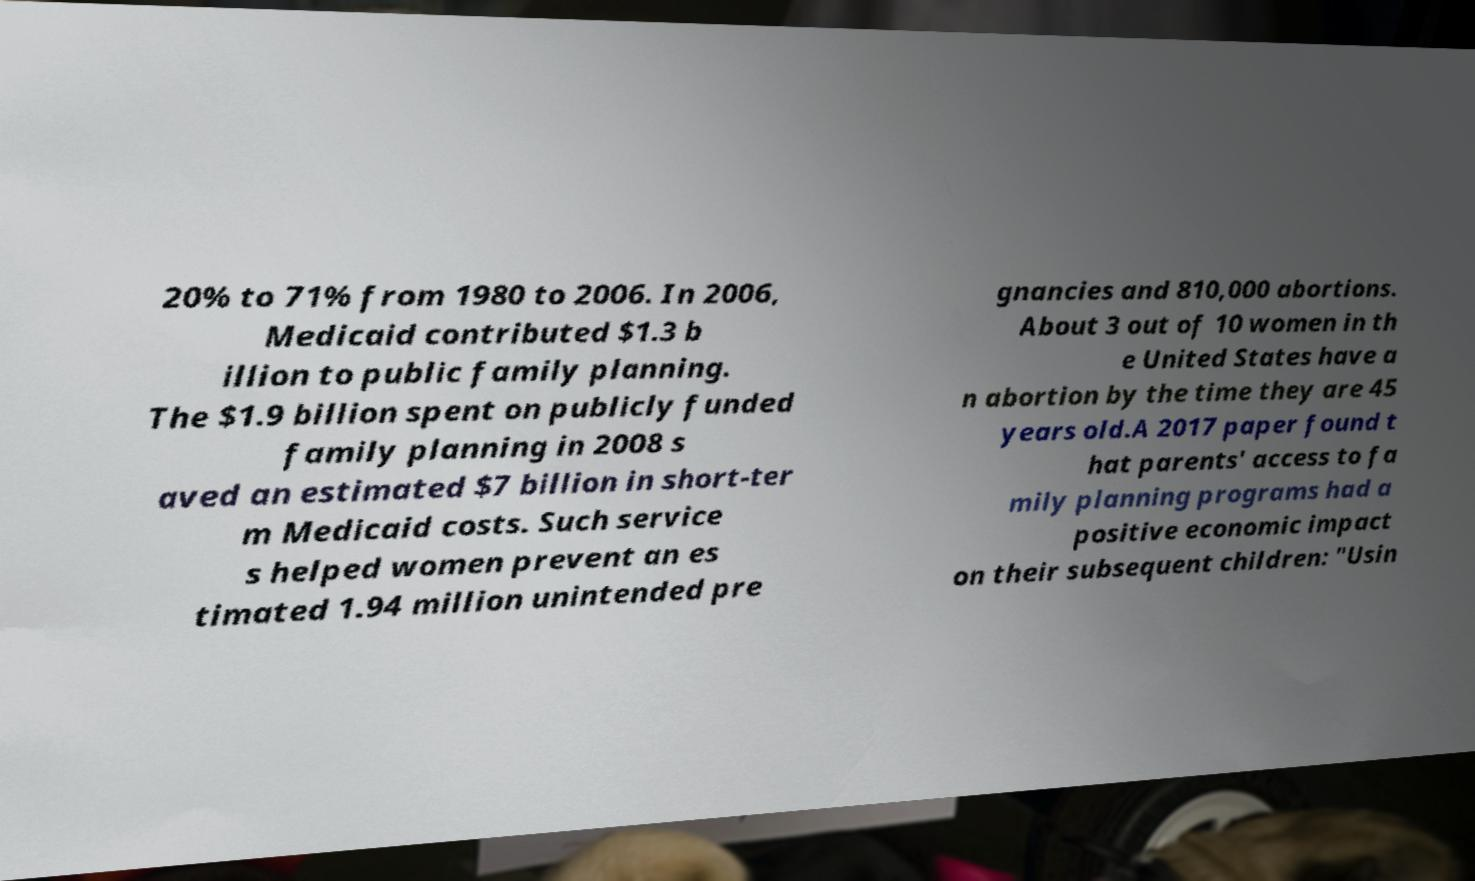I need the written content from this picture converted into text. Can you do that? 20% to 71% from 1980 to 2006. In 2006, Medicaid contributed $1.3 b illion to public family planning. The $1.9 billion spent on publicly funded family planning in 2008 s aved an estimated $7 billion in short-ter m Medicaid costs. Such service s helped women prevent an es timated 1.94 million unintended pre gnancies and 810,000 abortions. About 3 out of 10 women in th e United States have a n abortion by the time they are 45 years old.A 2017 paper found t hat parents' access to fa mily planning programs had a positive economic impact on their subsequent children: "Usin 